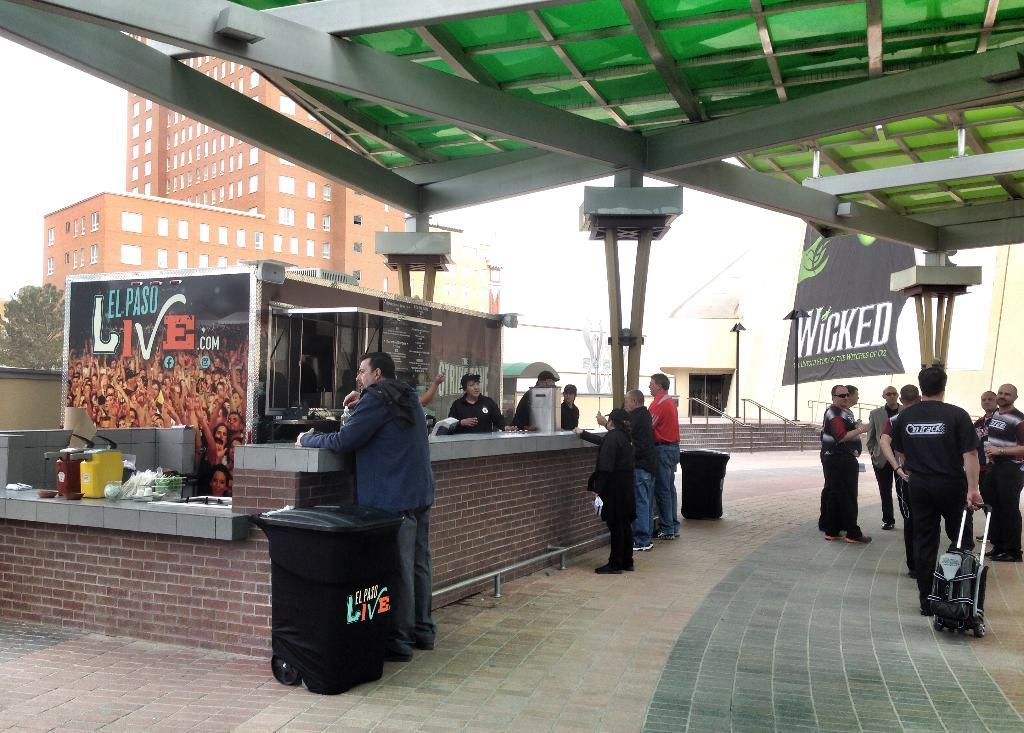What can be seen in the image involving people? There are persons standing in the image. What objects are present for waste disposal? There are two trash bins in the image. What type of structures are visible in the image? There are buildings in the image. What type of vegetation is present in the image? There are trees in the image. What type of shelter is available in the image? There is a roof for shelter in the image. What is visible in the background of the image? The sky is visible in the image. What flavor of cover is being used by the persons in the image? There is no mention of a cover or flavor in the image; it features persons standing, trash bins, buildings, trees, a roof, and the sky. 